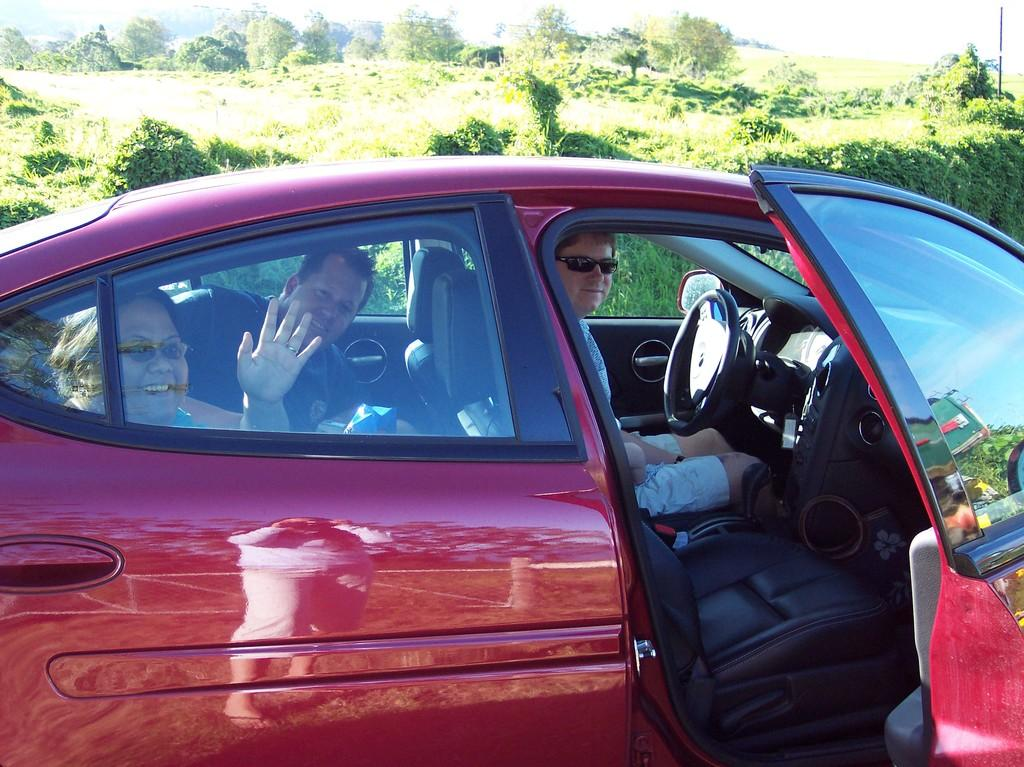What is the main subject of the image? The main subject of the image is a car. What is happening with the people in the image? There are people sitting inside the car. What is the state of the car door? The car door is open. What can be seen in the background of the image? There are trees and plants on the ground behind the car. How many dogs are leading the car in the image? There are no dogs present in the image, and they are not leading the car. What type of grape is being used to decorate the car in the image? There is no grape present in the image, and it is not being used to decorate the car. 